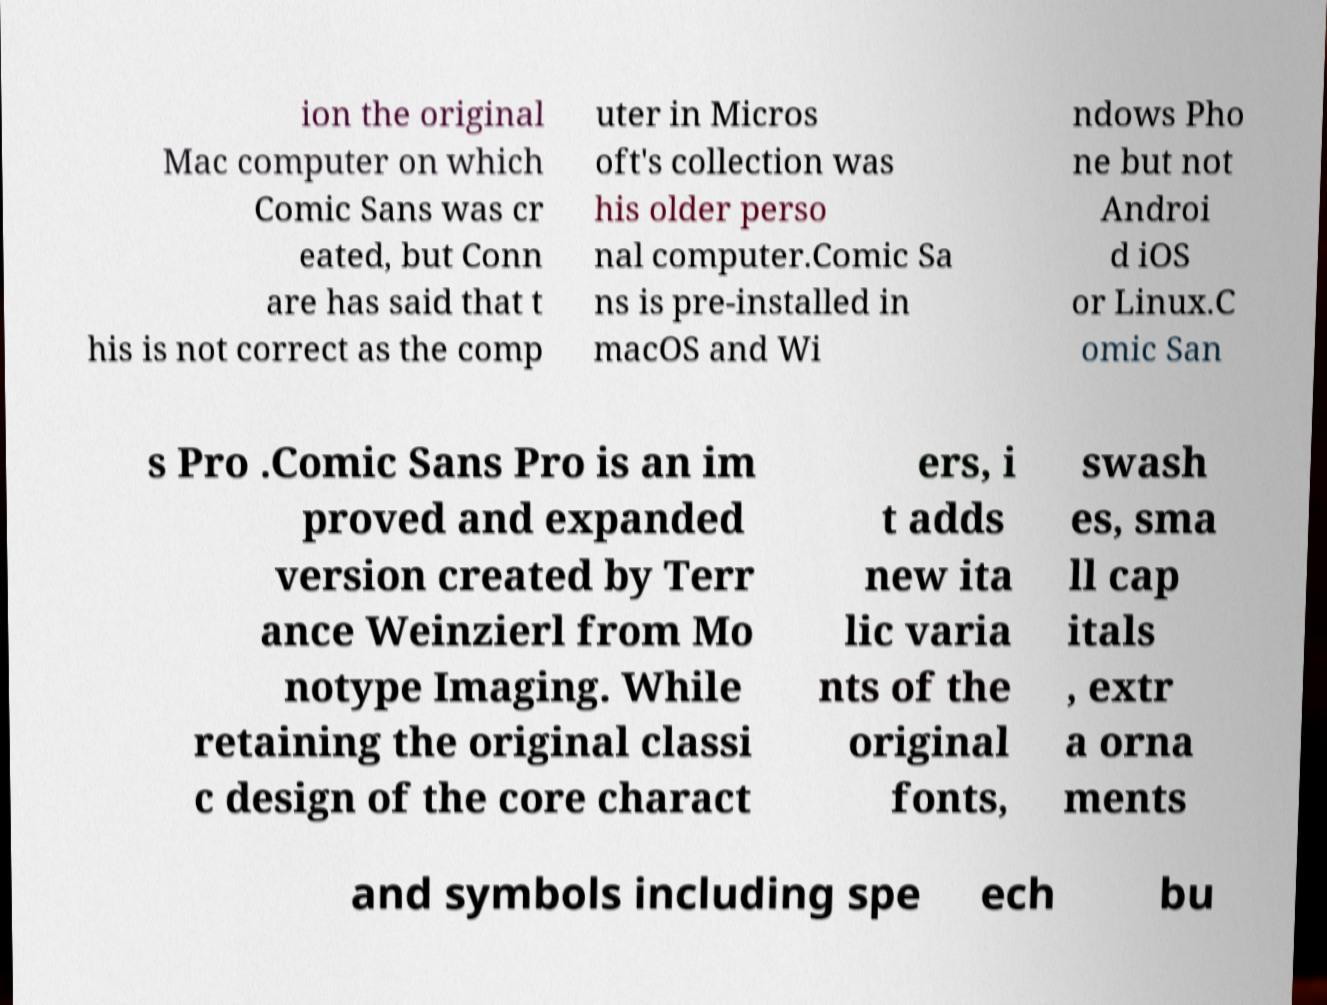Could you assist in decoding the text presented in this image and type it out clearly? ion the original Mac computer on which Comic Sans was cr eated, but Conn are has said that t his is not correct as the comp uter in Micros oft's collection was his older perso nal computer.Comic Sa ns is pre-installed in macOS and Wi ndows Pho ne but not Androi d iOS or Linux.C omic San s Pro .Comic Sans Pro is an im proved and expanded version created by Terr ance Weinzierl from Mo notype Imaging. While retaining the original classi c design of the core charact ers, i t adds new ita lic varia nts of the original fonts, swash es, sma ll cap itals , extr a orna ments and symbols including spe ech bu 